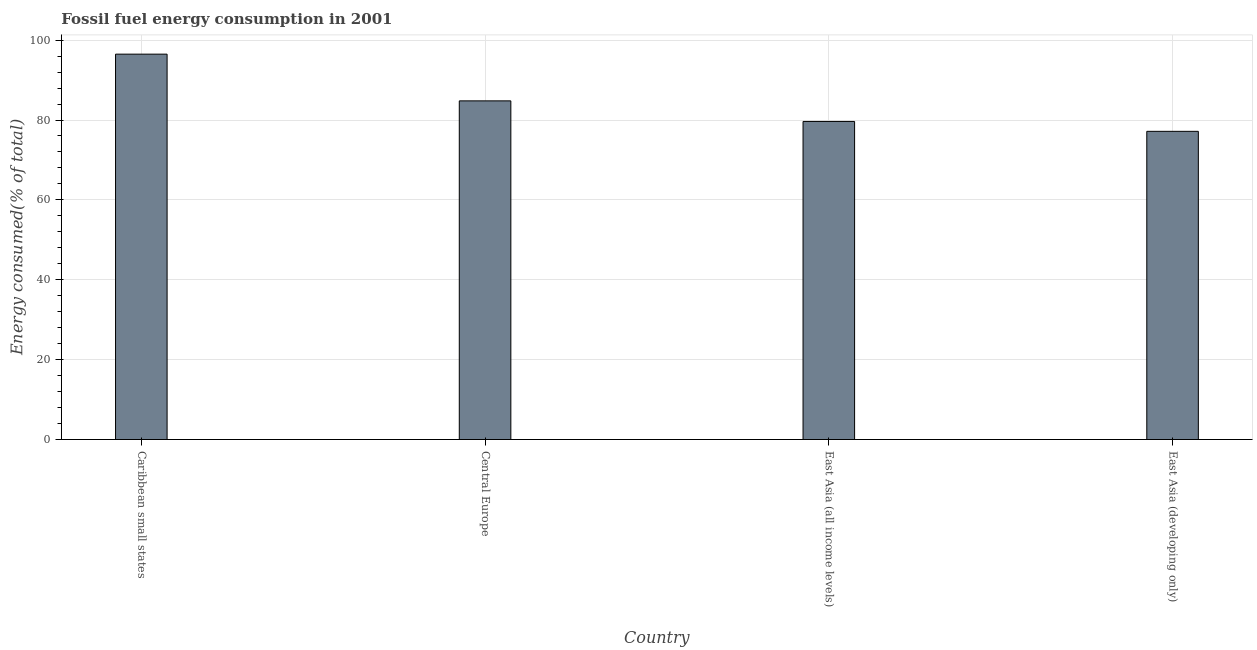Does the graph contain any zero values?
Your answer should be very brief. No. What is the title of the graph?
Make the answer very short. Fossil fuel energy consumption in 2001. What is the label or title of the X-axis?
Your answer should be compact. Country. What is the label or title of the Y-axis?
Provide a succinct answer. Energy consumed(% of total). What is the fossil fuel energy consumption in Central Europe?
Your answer should be very brief. 84.79. Across all countries, what is the maximum fossil fuel energy consumption?
Ensure brevity in your answer.  96.49. Across all countries, what is the minimum fossil fuel energy consumption?
Ensure brevity in your answer.  77.17. In which country was the fossil fuel energy consumption maximum?
Ensure brevity in your answer.  Caribbean small states. In which country was the fossil fuel energy consumption minimum?
Provide a succinct answer. East Asia (developing only). What is the sum of the fossil fuel energy consumption?
Provide a short and direct response. 338.09. What is the difference between the fossil fuel energy consumption in Caribbean small states and East Asia (developing only)?
Your answer should be very brief. 19.33. What is the average fossil fuel energy consumption per country?
Make the answer very short. 84.52. What is the median fossil fuel energy consumption?
Provide a short and direct response. 82.22. In how many countries, is the fossil fuel energy consumption greater than 96 %?
Your answer should be compact. 1. What is the ratio of the fossil fuel energy consumption in Central Europe to that in East Asia (all income levels)?
Your response must be concise. 1.06. Is the fossil fuel energy consumption in Central Europe less than that in East Asia (all income levels)?
Give a very brief answer. No. What is the difference between the highest and the second highest fossil fuel energy consumption?
Provide a succinct answer. 11.7. Is the sum of the fossil fuel energy consumption in Central Europe and East Asia (all income levels) greater than the maximum fossil fuel energy consumption across all countries?
Provide a succinct answer. Yes. What is the difference between the highest and the lowest fossil fuel energy consumption?
Your response must be concise. 19.33. How many bars are there?
Make the answer very short. 4. Are all the bars in the graph horizontal?
Your response must be concise. No. How many countries are there in the graph?
Provide a short and direct response. 4. What is the difference between two consecutive major ticks on the Y-axis?
Offer a very short reply. 20. What is the Energy consumed(% of total) in Caribbean small states?
Your answer should be very brief. 96.49. What is the Energy consumed(% of total) of Central Europe?
Keep it short and to the point. 84.79. What is the Energy consumed(% of total) of East Asia (all income levels)?
Provide a short and direct response. 79.64. What is the Energy consumed(% of total) in East Asia (developing only)?
Offer a terse response. 77.17. What is the difference between the Energy consumed(% of total) in Caribbean small states and Central Europe?
Ensure brevity in your answer.  11.7. What is the difference between the Energy consumed(% of total) in Caribbean small states and East Asia (all income levels)?
Give a very brief answer. 16.85. What is the difference between the Energy consumed(% of total) in Caribbean small states and East Asia (developing only)?
Offer a terse response. 19.33. What is the difference between the Energy consumed(% of total) in Central Europe and East Asia (all income levels)?
Your answer should be very brief. 5.15. What is the difference between the Energy consumed(% of total) in Central Europe and East Asia (developing only)?
Keep it short and to the point. 7.63. What is the difference between the Energy consumed(% of total) in East Asia (all income levels) and East Asia (developing only)?
Your response must be concise. 2.48. What is the ratio of the Energy consumed(% of total) in Caribbean small states to that in Central Europe?
Give a very brief answer. 1.14. What is the ratio of the Energy consumed(% of total) in Caribbean small states to that in East Asia (all income levels)?
Ensure brevity in your answer.  1.21. What is the ratio of the Energy consumed(% of total) in Caribbean small states to that in East Asia (developing only)?
Provide a succinct answer. 1.25. What is the ratio of the Energy consumed(% of total) in Central Europe to that in East Asia (all income levels)?
Your answer should be very brief. 1.06. What is the ratio of the Energy consumed(% of total) in Central Europe to that in East Asia (developing only)?
Make the answer very short. 1.1. What is the ratio of the Energy consumed(% of total) in East Asia (all income levels) to that in East Asia (developing only)?
Your answer should be compact. 1.03. 